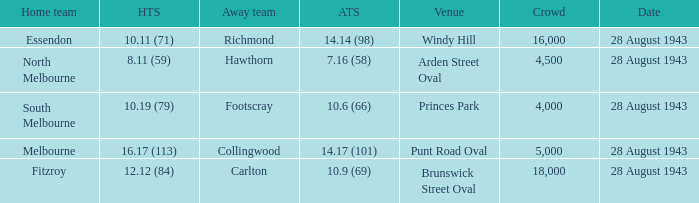What game showed a home team score of 8.11 (59)? 28 August 1943. 